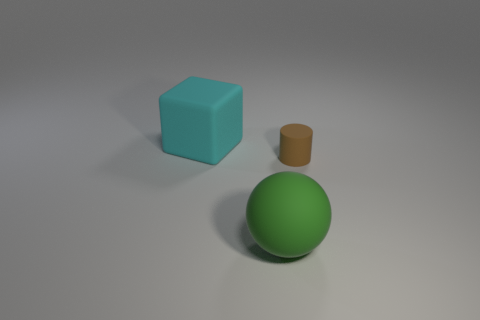Add 3 matte objects. How many objects exist? 6 Subtract 1 cylinders. How many cylinders are left? 0 Subtract all red blocks. Subtract all brown spheres. How many blocks are left? 1 Subtract all blue things. Subtract all green spheres. How many objects are left? 2 Add 2 cyan rubber objects. How many cyan rubber objects are left? 3 Add 2 tiny gray matte things. How many tiny gray matte things exist? 2 Subtract 0 brown spheres. How many objects are left? 3 Subtract all cylinders. How many objects are left? 2 